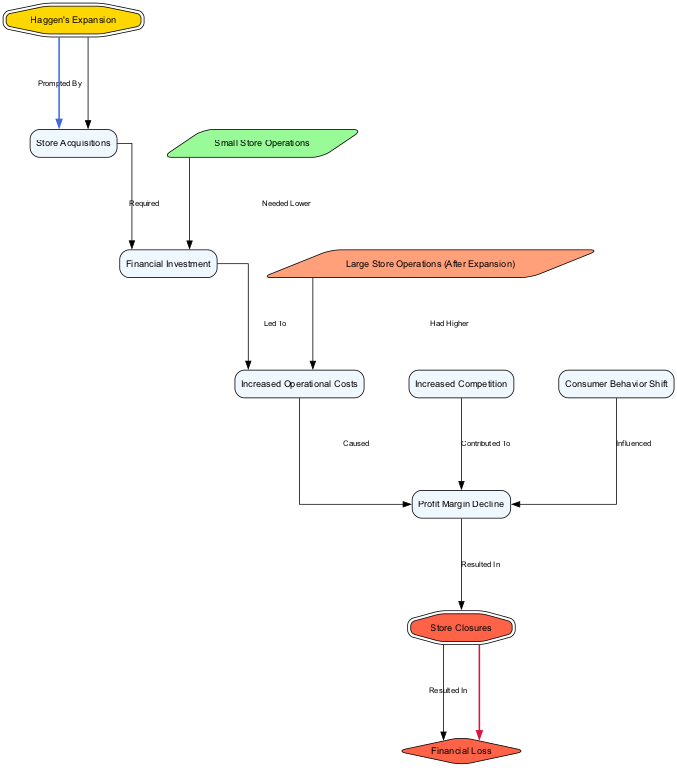What prompted Haggen's expansion? The diagram indicates that Haggen's expansion was prompted by the store acquisitions. This link defines the relationship between the two nodes, showing that acquiring new stores was the reason for expanding.
Answer: Store Acquisitions What was required for store acquisitions? According to the diagram, the store acquisitions required financial investment. This is indicated by the edge going from store acquisitions to financial investment, labeled as "Required."
Answer: Financial Investment What caused the decline in profit margins? The diagram shows that increased operational costs caused the profit margin decline. The edge moving from operational costs to profit margin decline illustrates this direct cause-and-effect relationship.
Answer: Increased Operational Costs What resulted from the profit margin decline? The diagram indicates that the profit margin decline resulted in store closures. This relationship is shown by the edge leading from profit margin decline to closure, clearly illustrating the sequence of events.
Answer: Store Closures How did competition contribute to the profit margin decline? The diagram illustrates that increased competition contributed to the profit margin decline. This is depicted by the edge from the competition node to the profit margin decline node, indicating a contributing factor.
Answer: Contributed To How do the operational costs of large store operations compare to small store operations? The diagram details that large store operations had higher operational costs compared to small store operations. The edge from large store operations to operational costs signifies their relationship.
Answer: Had Higher What is the final financial outcome of the store closures? The diagram shows that store closures resulted in financial loss. The edge connecting closure to financial loss indicates this direct consequence of the previous events outlined in the diagram.
Answer: Financial Loss What influenced the profit margin decline from consumer behavior? The consumer behaviour shift influenced the profit margin decline, according to the diagram. An edge connects consumer behaviour to profit margin decline, indicating their relationship.
Answer: Influenced How many nodes are represented in the diagram? The diagram includes ten nodes, each representing a key aspect of the financial implications of Haggen's expansion and closures. This count can be directly obtained by reviewing the nodes listed in the diagram.
Answer: Ten 